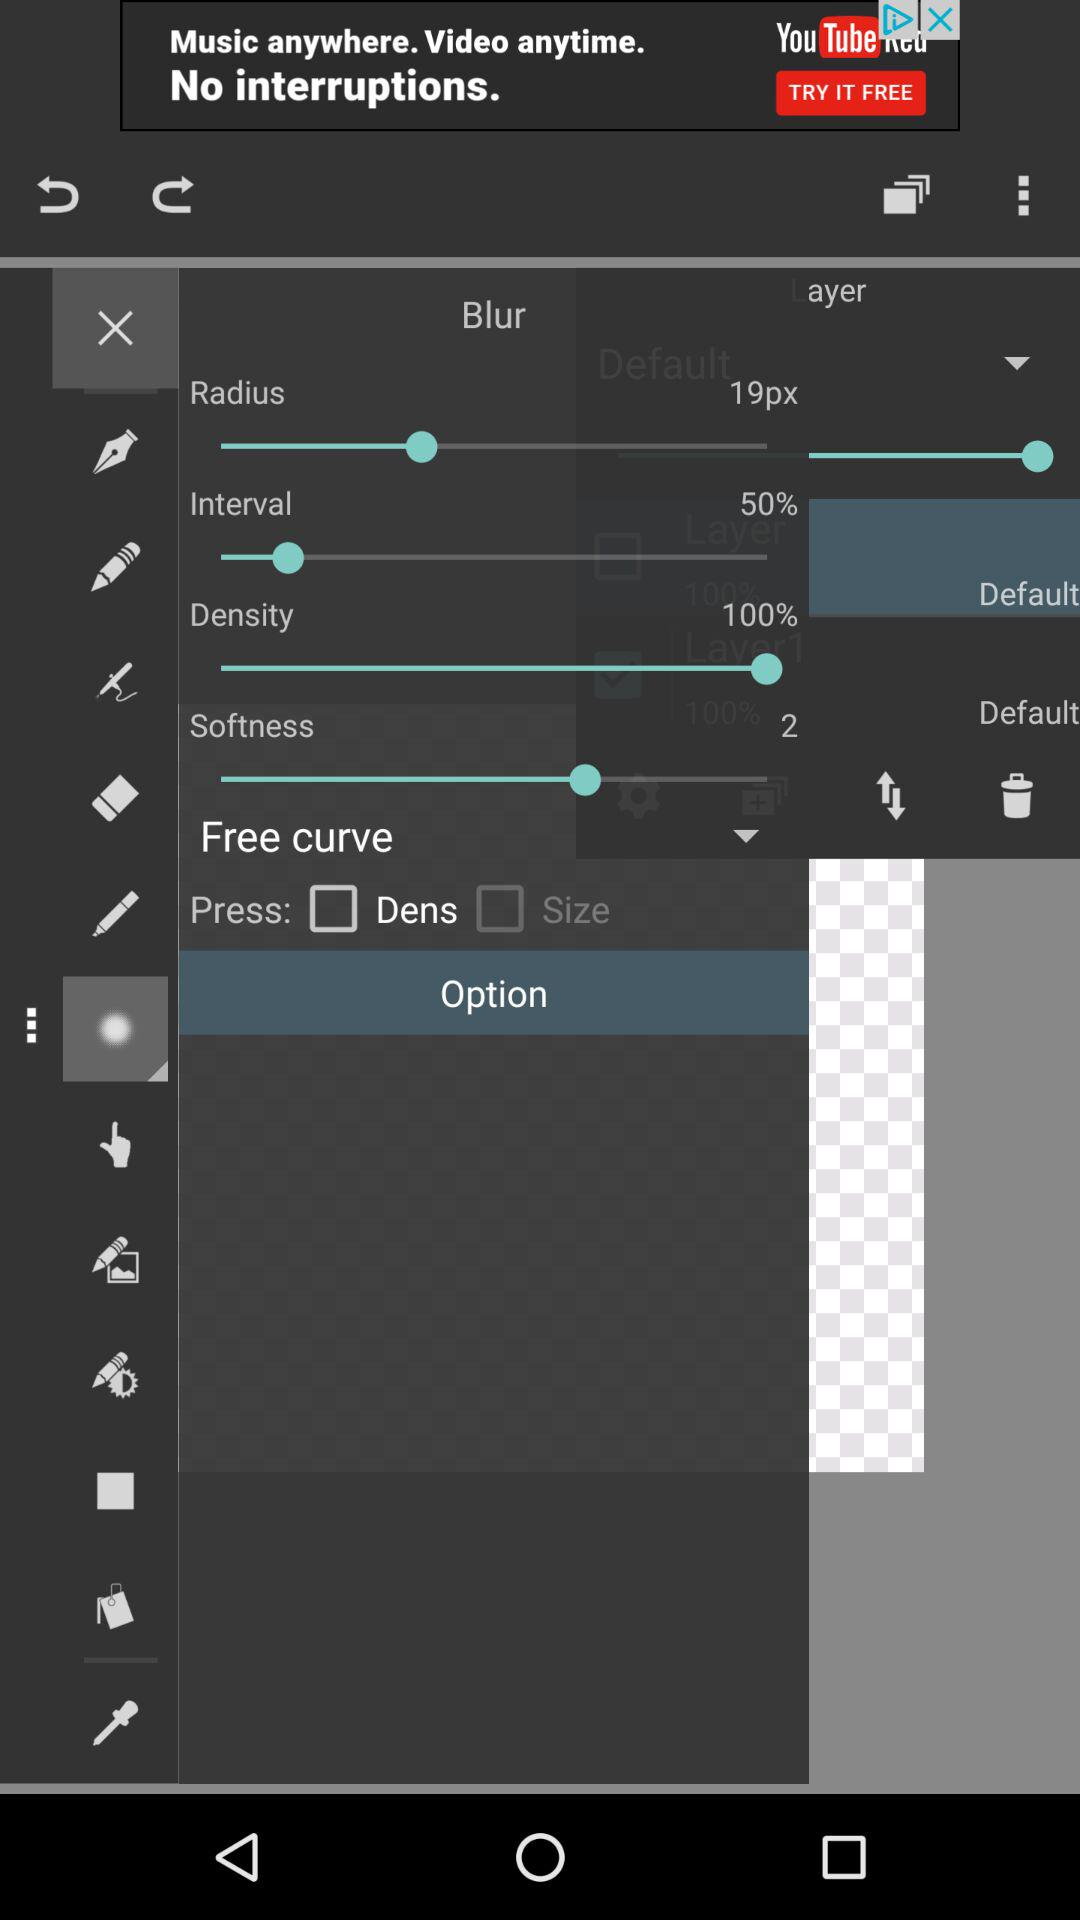What is the selected percentage of the interval? The selected percentage is 50. 